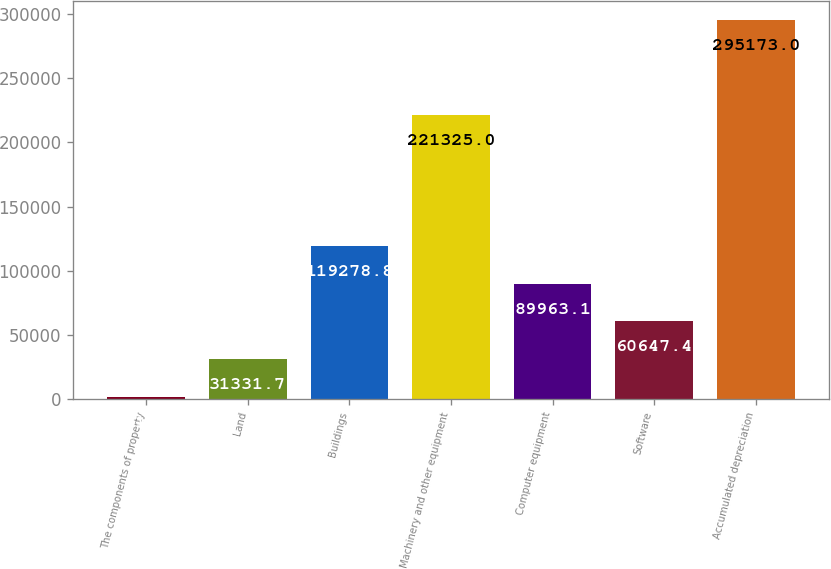Convert chart. <chart><loc_0><loc_0><loc_500><loc_500><bar_chart><fcel>The components of property<fcel>Land<fcel>Buildings<fcel>Machinery and other equipment<fcel>Computer equipment<fcel>Software<fcel>Accumulated depreciation<nl><fcel>2016<fcel>31331.7<fcel>119279<fcel>221325<fcel>89963.1<fcel>60647.4<fcel>295173<nl></chart> 